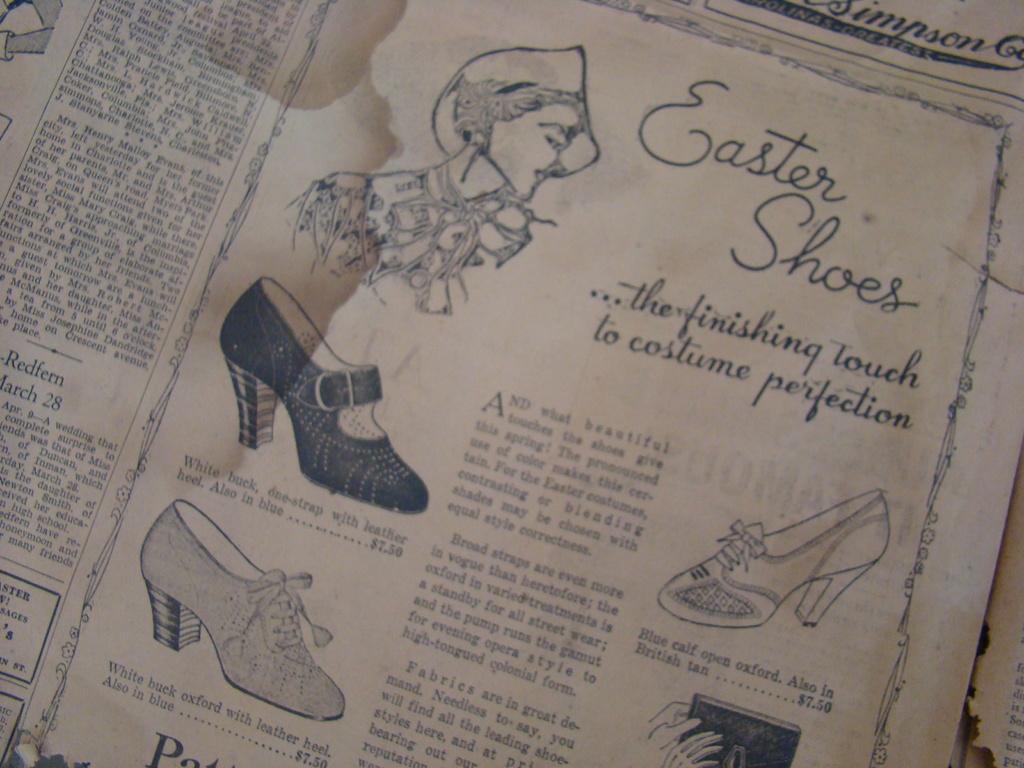Can you describe this image briefly? In this image, It looks like a paper with the pictures and letters on it. 